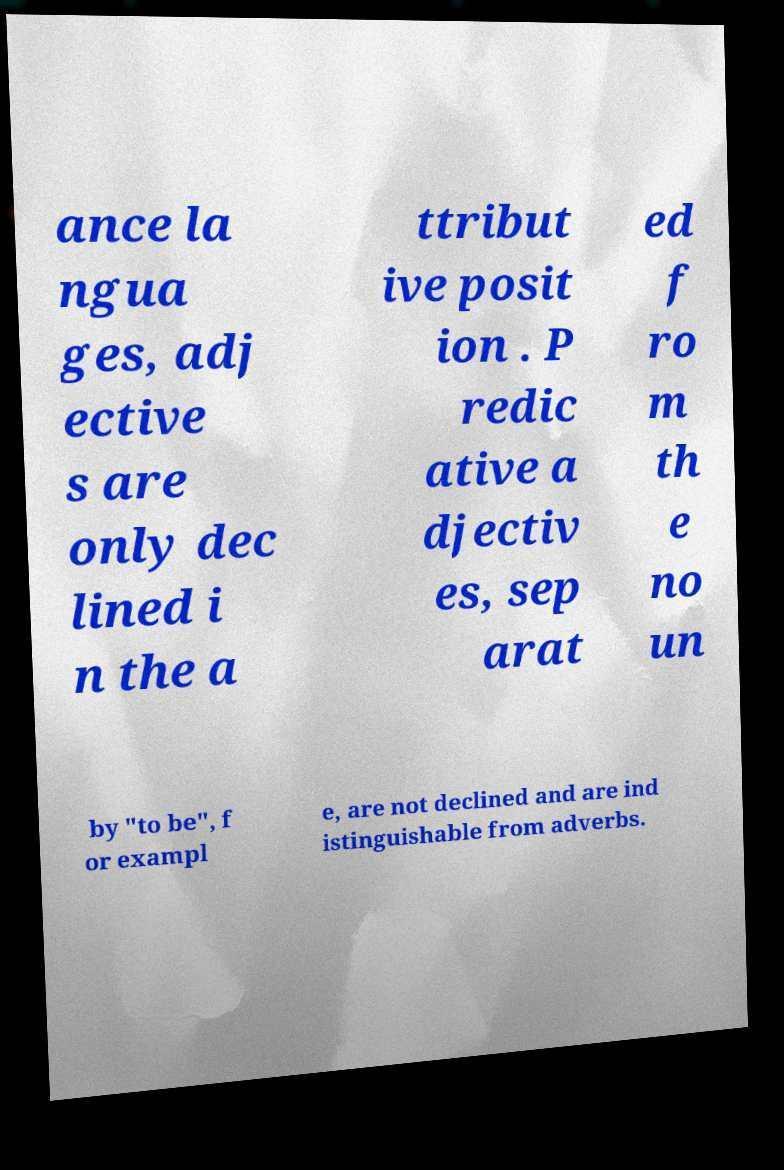Could you assist in decoding the text presented in this image and type it out clearly? ance la ngua ges, adj ective s are only dec lined i n the a ttribut ive posit ion . P redic ative a djectiv es, sep arat ed f ro m th e no un by "to be", f or exampl e, are not declined and are ind istinguishable from adverbs. 